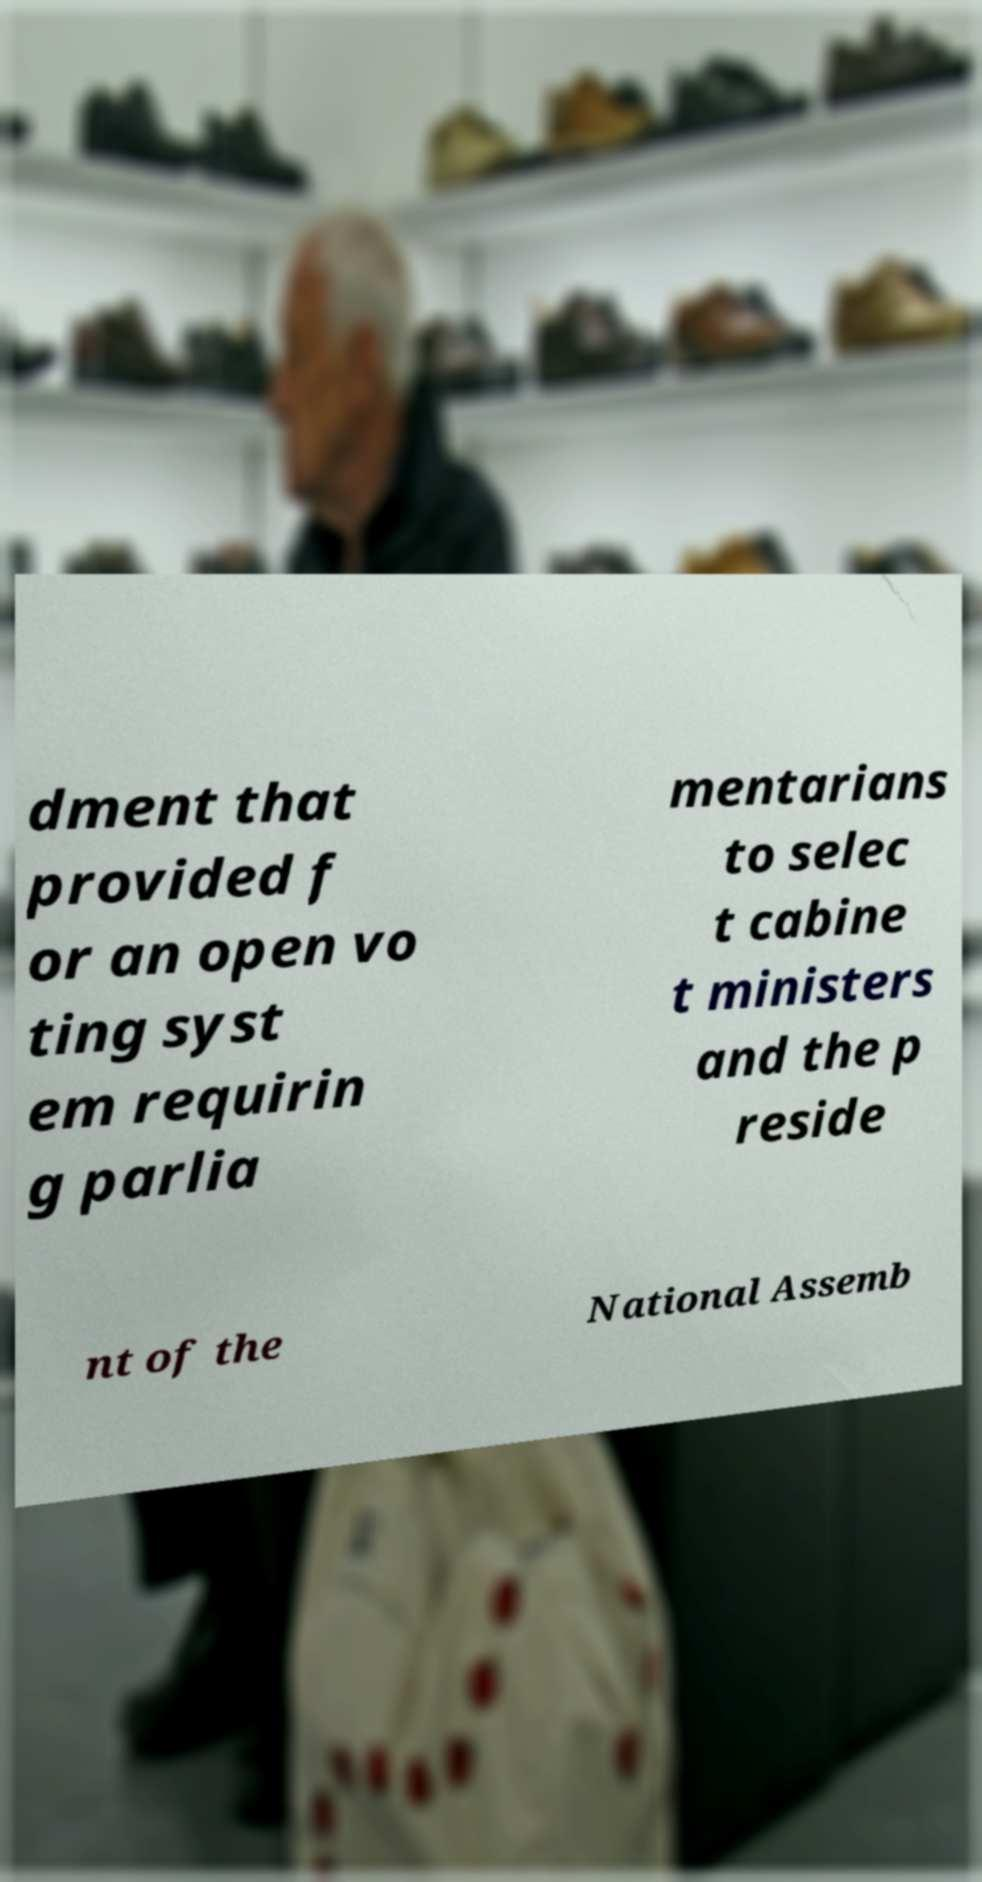Can you read and provide the text displayed in the image?This photo seems to have some interesting text. Can you extract and type it out for me? dment that provided f or an open vo ting syst em requirin g parlia mentarians to selec t cabine t ministers and the p reside nt of the National Assemb 